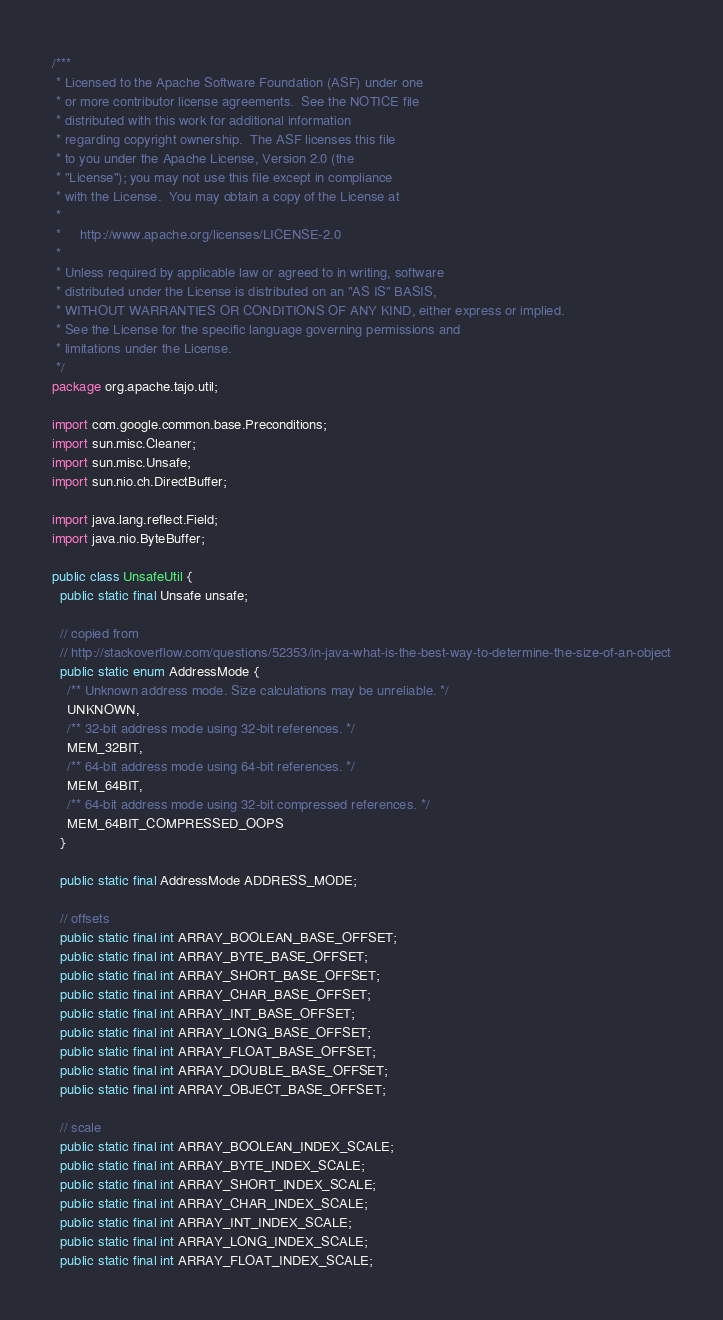<code> <loc_0><loc_0><loc_500><loc_500><_Java_>/***
 * Licensed to the Apache Software Foundation (ASF) under one
 * or more contributor license agreements.  See the NOTICE file
 * distributed with this work for additional information
 * regarding copyright ownership.  The ASF licenses this file
 * to you under the Apache License, Version 2.0 (the
 * "License"); you may not use this file except in compliance
 * with the License.  You may obtain a copy of the License at
 *
 *     http://www.apache.org/licenses/LICENSE-2.0
 *
 * Unless required by applicable law or agreed to in writing, software
 * distributed under the License is distributed on an "AS IS" BASIS,
 * WITHOUT WARRANTIES OR CONDITIONS OF ANY KIND, either express or implied.
 * See the License for the specific language governing permissions and
 * limitations under the License.
 */
package org.apache.tajo.util;

import com.google.common.base.Preconditions;
import sun.misc.Cleaner;
import sun.misc.Unsafe;
import sun.nio.ch.DirectBuffer;

import java.lang.reflect.Field;
import java.nio.ByteBuffer;

public class UnsafeUtil {
  public static final Unsafe unsafe;

  // copied from
  // http://stackoverflow.com/questions/52353/in-java-what-is-the-best-way-to-determine-the-size-of-an-object
  public static enum AddressMode {
    /** Unknown address mode. Size calculations may be unreliable. */
    UNKNOWN,
    /** 32-bit address mode using 32-bit references. */
    MEM_32BIT,
    /** 64-bit address mode using 64-bit references. */
    MEM_64BIT,
    /** 64-bit address mode using 32-bit compressed references. */
    MEM_64BIT_COMPRESSED_OOPS
  }

  public static final AddressMode ADDRESS_MODE;

  // offsets
  public static final int ARRAY_BOOLEAN_BASE_OFFSET;
  public static final int ARRAY_BYTE_BASE_OFFSET;
  public static final int ARRAY_SHORT_BASE_OFFSET;
  public static final int ARRAY_CHAR_BASE_OFFSET;
  public static final int ARRAY_INT_BASE_OFFSET;
  public static final int ARRAY_LONG_BASE_OFFSET;
  public static final int ARRAY_FLOAT_BASE_OFFSET;
  public static final int ARRAY_DOUBLE_BASE_OFFSET;
  public static final int ARRAY_OBJECT_BASE_OFFSET;

  // scale
  public static final int ARRAY_BOOLEAN_INDEX_SCALE;
  public static final int ARRAY_BYTE_INDEX_SCALE;
  public static final int ARRAY_SHORT_INDEX_SCALE;
  public static final int ARRAY_CHAR_INDEX_SCALE;
  public static final int ARRAY_INT_INDEX_SCALE;
  public static final int ARRAY_LONG_INDEX_SCALE;
  public static final int ARRAY_FLOAT_INDEX_SCALE;</code> 